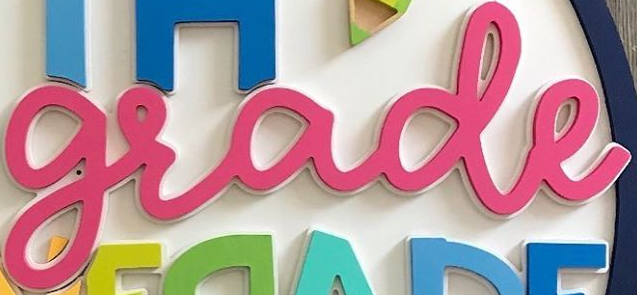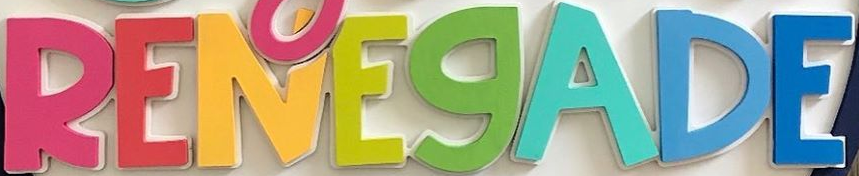What words are shown in these images in order, separated by a semicolon? grade; RENEGADE 